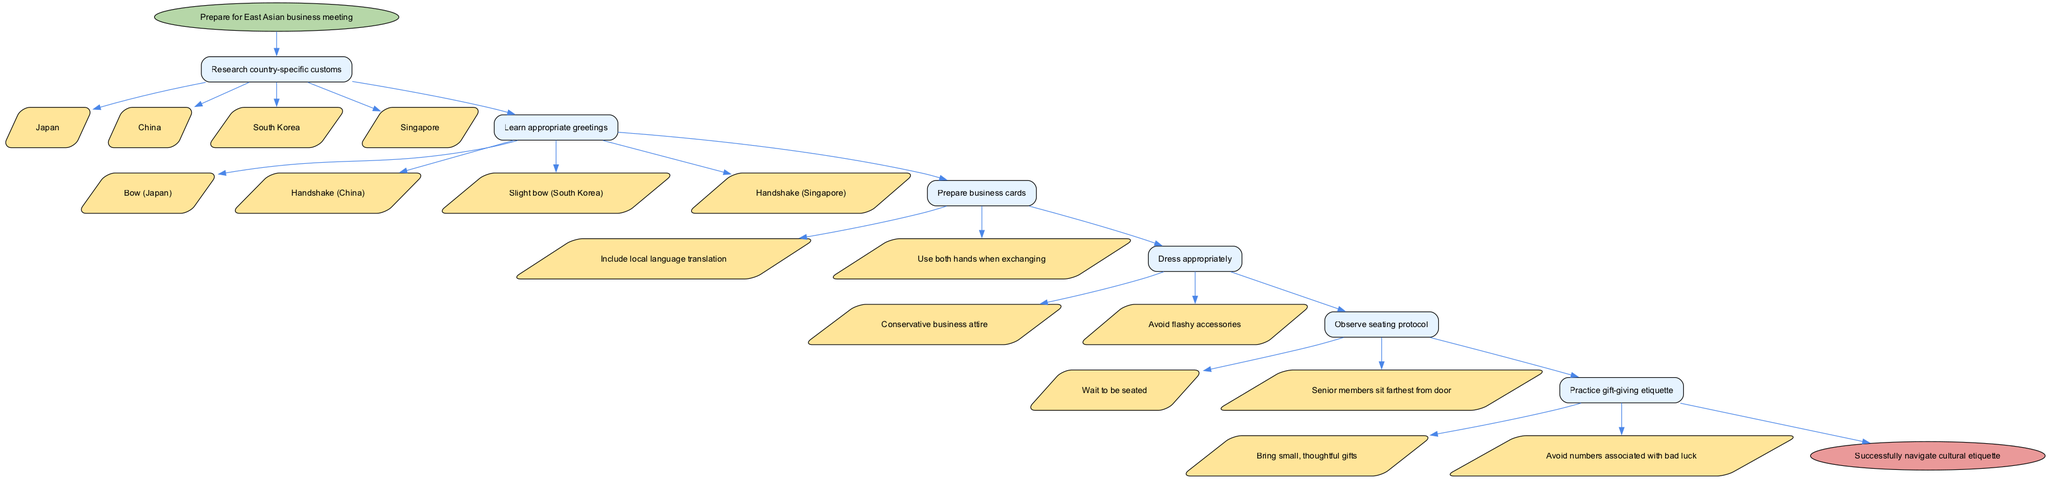What is the first step before attending an East Asian business meeting? The diagram shows that the first step is labeled "Prepare for East Asian business meeting." This indicates that initial preparation is essential before moving on to more specific actions.
Answer: Prepare for East Asian business meeting How many steps are involved in the flowchart? By counting the listed steps in the diagram, we can see there are a total of six steps leading to the final outcome. This includes the preparation and various customs to be considered.
Answer: 6 What should you do after researching country-specific customs? After completing the first step of researching customs, the diagram leads to the next step, which involves learning about appropriate greetings, as indicated in the flow of the chart.
Answer: Learn appropriate greetings In which step should you practice gift-giving etiquette? Looking at the flow of steps, the diagram positions "Practice gift-giving etiquette" as the sixth step. This shows it's one of the final preparations before successfully navigating cultural etiquette.
Answer: Step 6 What is the recommended dress code for business meetings according to the diagram? According to the steps outlined, "Dress appropriately" is specified as a step, indicating that conservative business attire and avoiding flashy accessories are important during meetings.
Answer: Conservative business attire What is an important aspect to include when preparing business cards? The diagram highlights that when preparing business cards, one should include local language translation, which is indicated as part of the preparations to ensure proper communication.
Answer: Include local language translation What is the seating protocol mentioned in the flowchart? The diagram states two options under "Observe seating protocol": to wait to be seated and that senior members sit farthest from the door. This suggests respecting hierarchy is important in seating arrangements.
Answer: Wait to be seated How are options presented in the diagram? The diagram presents options associated with each step using sub-nodes, where each option branches out distinctly under its respective step, showing different choices available at that point in the process.
Answer: Sub-nodes Why is the greeting method important in the business meeting steps? The flowchart emphasizes learning appropriate greetings as a significant step, highlighting the importance of cultural nuances in communication, which can influence first impressions in business settings.
Answer: Cultural nuances in communication 